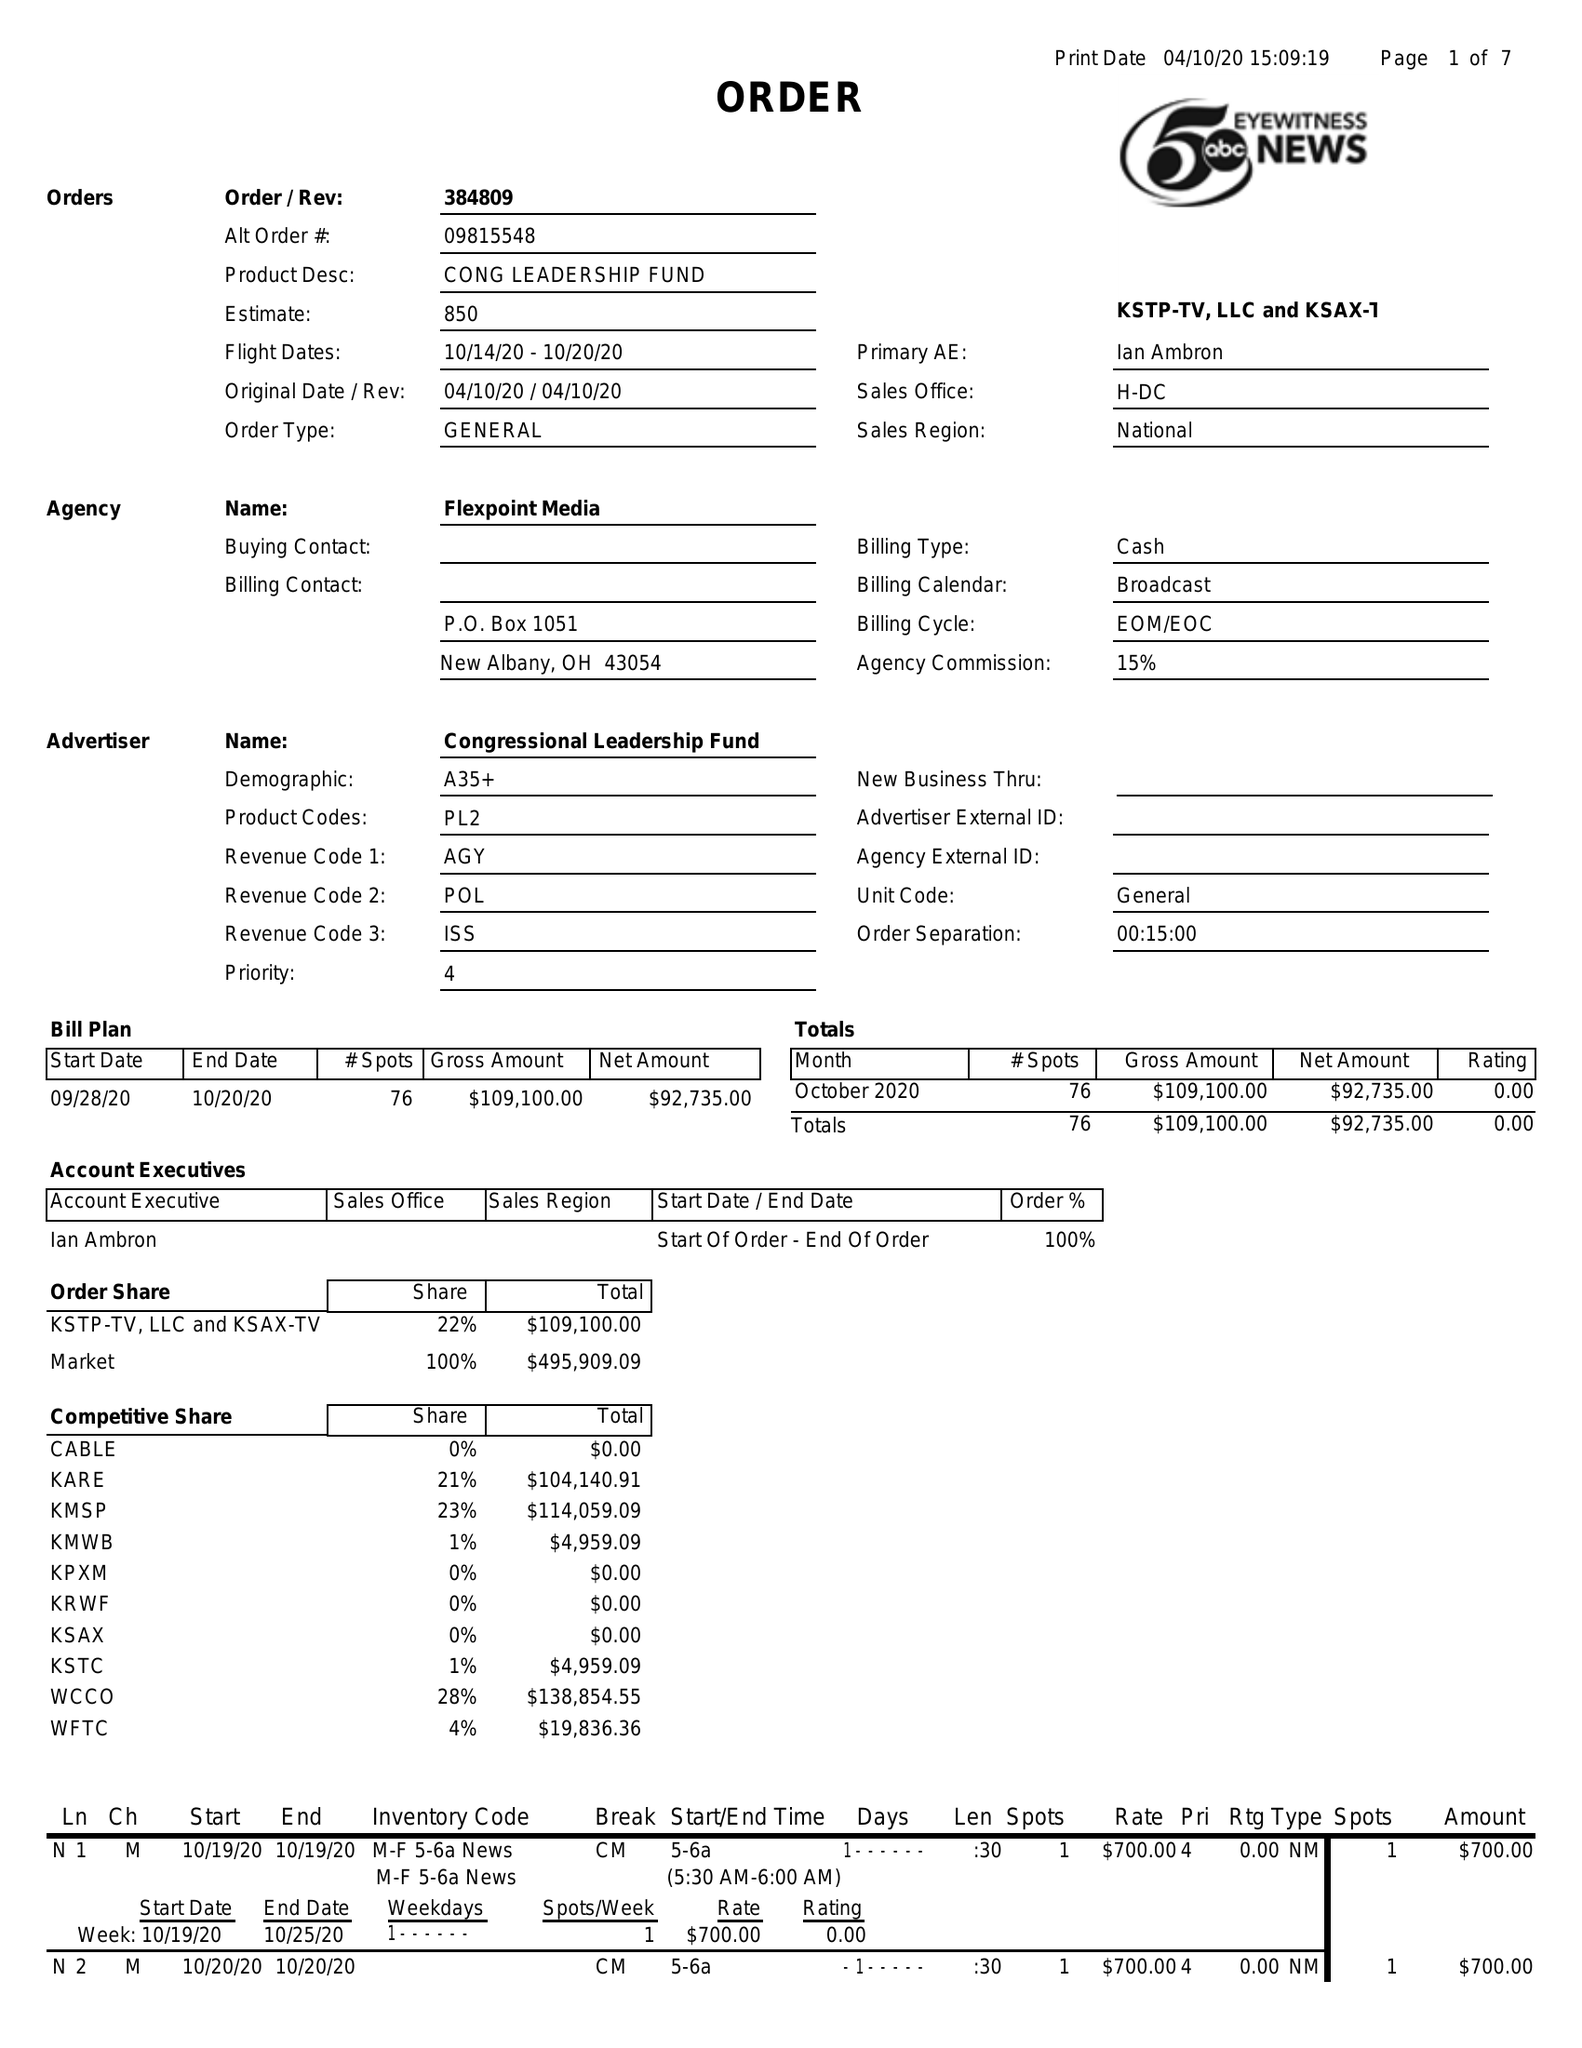What is the value for the gross_amount?
Answer the question using a single word or phrase. 109100.00 